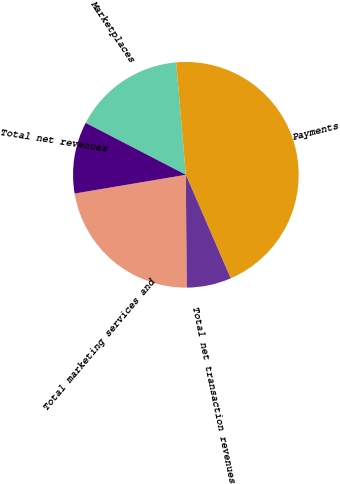Convert chart to OTSL. <chart><loc_0><loc_0><loc_500><loc_500><pie_chart><fcel>Marketplaces<fcel>Payments<fcel>Total net transaction revenues<fcel>Total marketing services and<fcel>Total net revenues<nl><fcel>16.03%<fcel>44.87%<fcel>6.41%<fcel>22.44%<fcel>10.26%<nl></chart> 